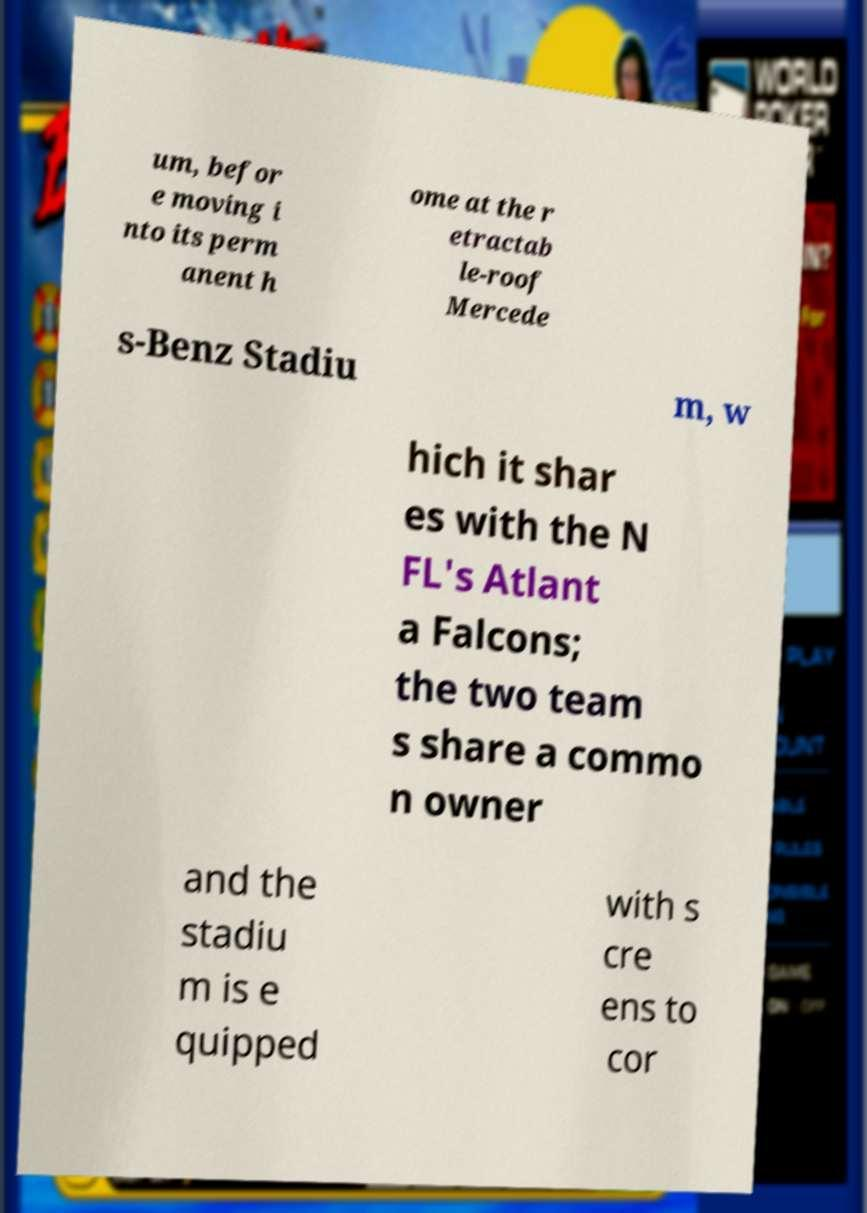For documentation purposes, I need the text within this image transcribed. Could you provide that? um, befor e moving i nto its perm anent h ome at the r etractab le-roof Mercede s-Benz Stadiu m, w hich it shar es with the N FL's Atlant a Falcons; the two team s share a commo n owner and the stadiu m is e quipped with s cre ens to cor 